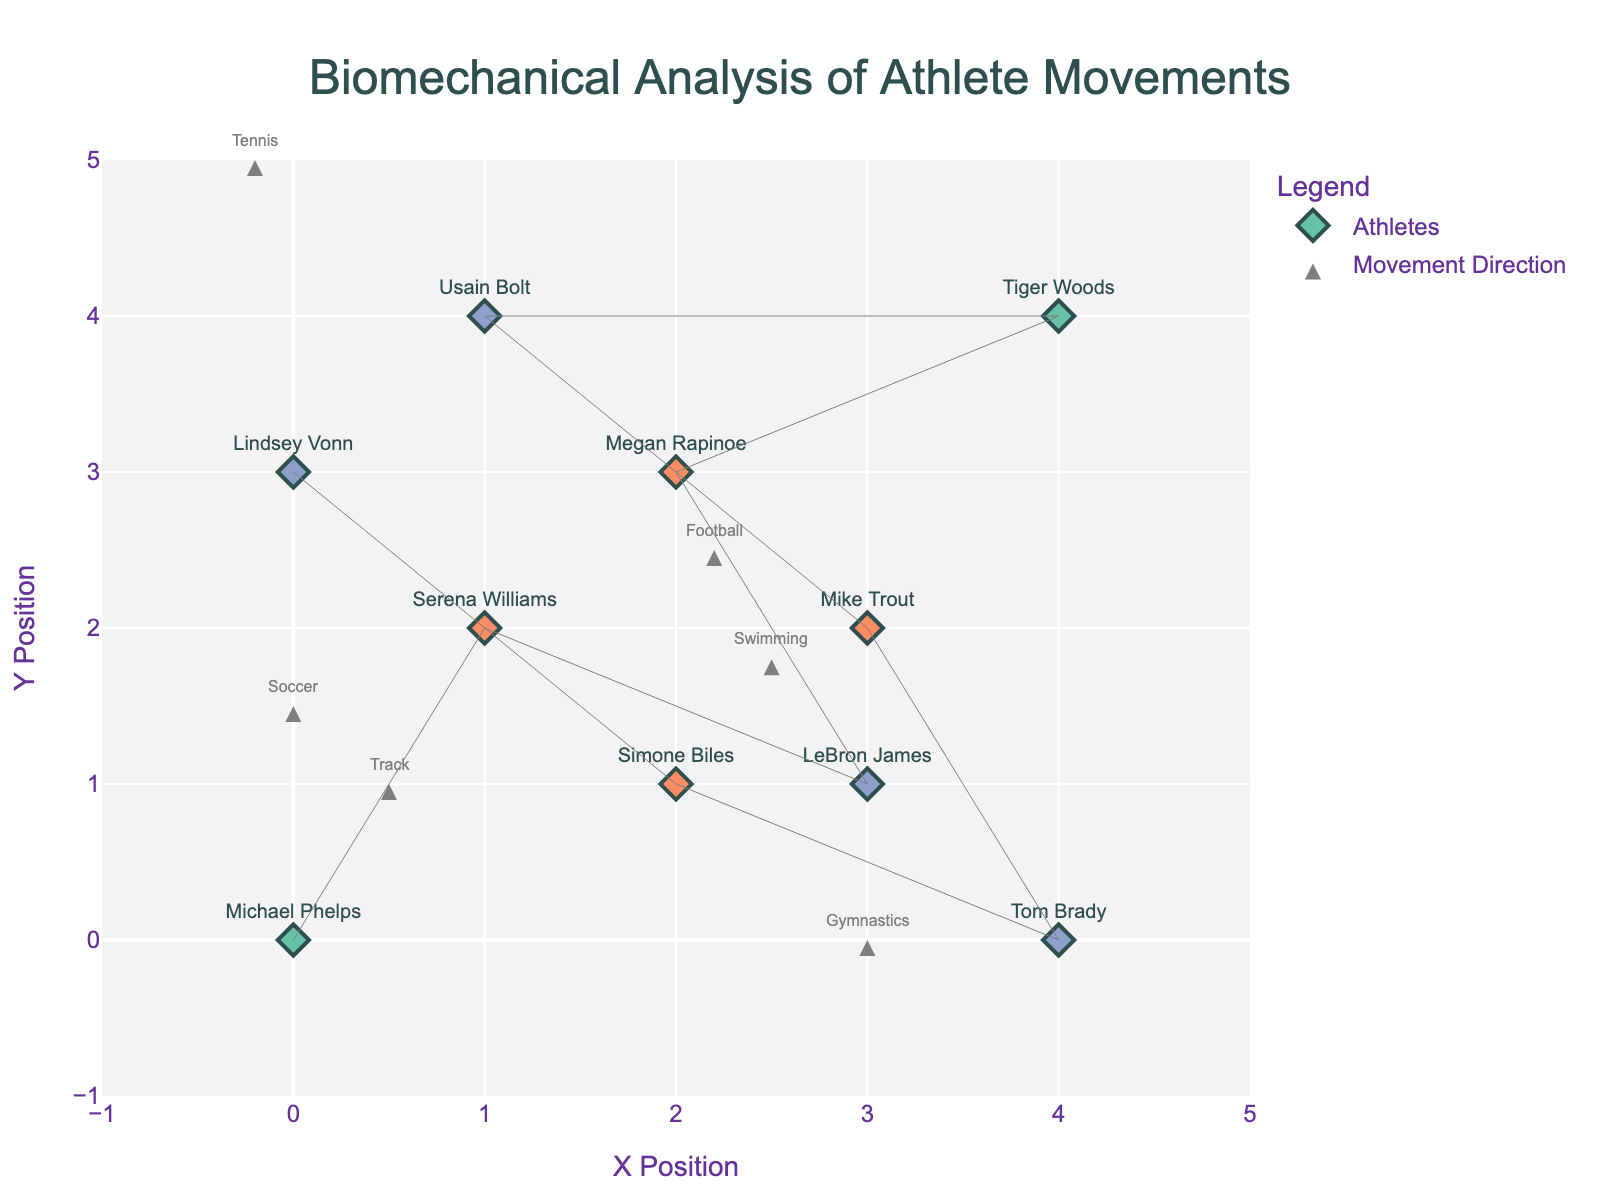What is the title of this figure? To find the title, refer to the text at the top center of the plot layout.
Answer: Biomechanical Analysis of Athlete Movements How many athletes have a high impact from their movements? Look for markers in the figure that are colored accordingly (blue for high impact) and count them.
Answer: 4 Which athlete has the highest movement in the positive x direction? Compare the u values (x direction movements) and find the highest value. Mike Trout's u value is 3.0, which is the highest.
Answer: Mike Trout Where does Simone Biles start and end her movement? Simone's starting position is at the coordinates (2, 1). Her movements are (u=1.0, v=-1.0), so add these to her starting position to find the end position (3, 0).
Answer: Starts at (2, 1) and ends at (3, 0) Which sport shows the movement with the highest vertical impact? Compare the absolute values of v components to find the highest one. Serena Williams in Tennis has v = 3.0, the highest movement in the vertical direction.
Answer: Tennis What is the average x position of all the athletes? Sum all the x positions (0 + 1 + 3 + 2 + 4 + 1 + 3 + 4 + 2 + 0 = 20) and then divide by the number of athletes (10). The average x position is 20/10.
Answer: 2 Which athletes' movements result in a medium impact? Identify the athletes categorized with medium impact and list their names. These are Serena Williams, Megan Rapinoe, Mike Trout, and Simone Biles.
Answer: Serena Williams, Megan Rapinoe, Mike Trout, Simone Biles Which sport appears at the coordinate (4, 0)? Look at the sport annotations near the coordinate (4, 0) on the figure.
Answer: Football Compare the movements of Usain Bolt and Lindsey Vonn. Who moves higher and by how much? Calculate the final y-coordinates for each athlete by adding the y and v values: Usain Bolt (y=4 + v=-3.0) = 1; Lindsey Vonn (y=3 + v=-2.0) = 1. Thus, both movements end at the same y-coordinate.
Answer: Both movements end at y=1; the difference is 0 How many athletes' movements end in the fourth quadrant? Check which athletes end in the fourth quadrant (x > 0 and y < 0). From the data: LeBron James and Simone Biles end in the fourth quadrant.
Answer: 2 